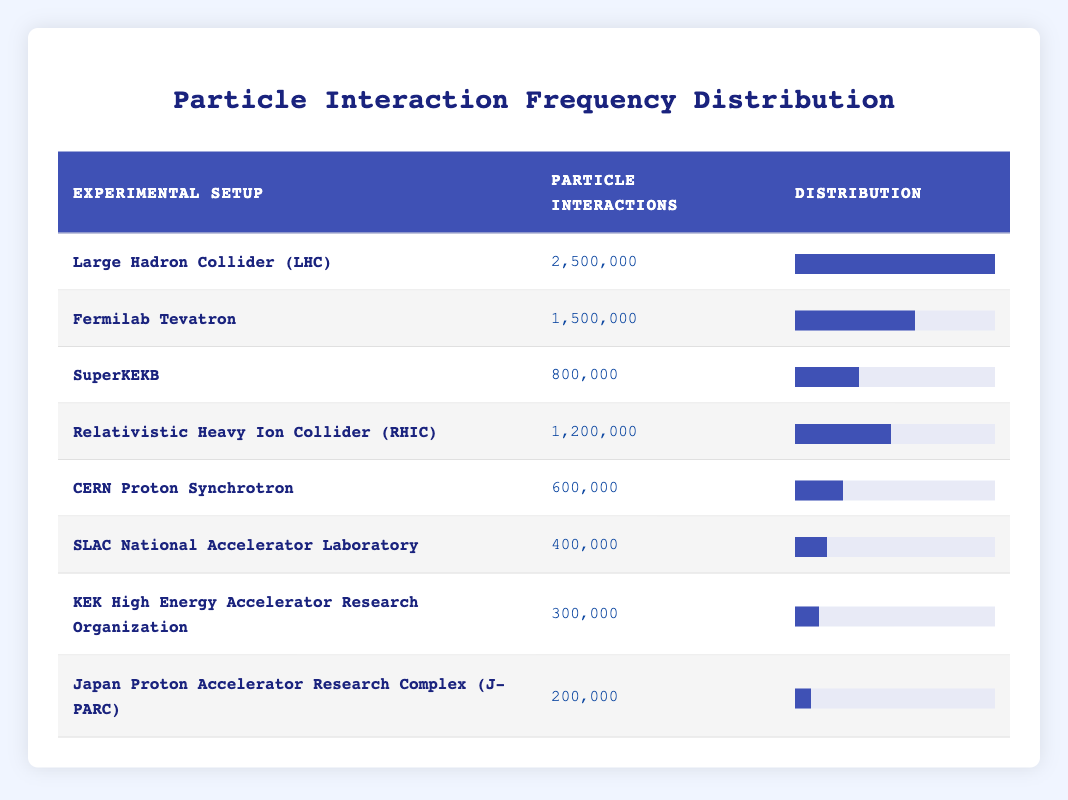What is the highest number of particle interactions observed? The table shows the particle interactions for each experimental setup. The highest value is for the Large Hadron Collider (LHC) with 2,500,000 interactions.
Answer: 2,500,000 How many more particle interactions does the Fermilab Tevatron have than the SLAC National Accelerator Laboratory? The Fermilab Tevatron has 1,500,000 interactions, while the SLAC National Accelerator Laboratory has 400,000 interactions. The difference is calculated as 1,500,000 - 400,000 = 1,100,000.
Answer: 1,100,000 Is the number of particle interactions at the SuperKEKB greater than that at the CERN Proton Synchrotron? The SuperKEKB has 800,000 interactions and the CERN Proton Synchrotron has 600,000. Since 800,000 is greater than 600,000, the answer is yes.
Answer: Yes What is the total count of particle interactions across all setups? To find the total, we add all the interactions: 2,500,000 + 1,500,000 + 800,000 + 1,200,000 + 600,000 + 400,000 + 300,000 + 200,000 = 8,600,000.
Answer: 8,600,000 Which experimental setup has the lowest number of particle interactions? Among all setups, Japan Proton Accelerator Research Complex (J-PARC) has the lowest count of 200,000 interactions.
Answer: Japan Proton Accelerator Research Complex (J-PARC) What is the average number of particle interactions across the listed experimental setups? There are 8 setups, and the total number of interactions is 8,600,000. The average is calculated as 8,600,000 / 8 = 1,075,000.
Answer: 1,075,000 Does the Relativistic Heavy Ion Collider (RHIC) have more interactions than the average? The RHIC has 1,200,000 interactions. The average was calculated as 1,075,000. Since 1,200,000 is greater than 1,075,000, the answer is yes.
Answer: Yes What is the proportion of interactions recorded at the CERN Proton Synchrotron compared to the LHC? The CERN Proton Synchrotron has 600,000 interactions and LHC has 2,500,000. The proportion is 600,000 / 2,500,000 = 0.24, or 24%.
Answer: 24% 